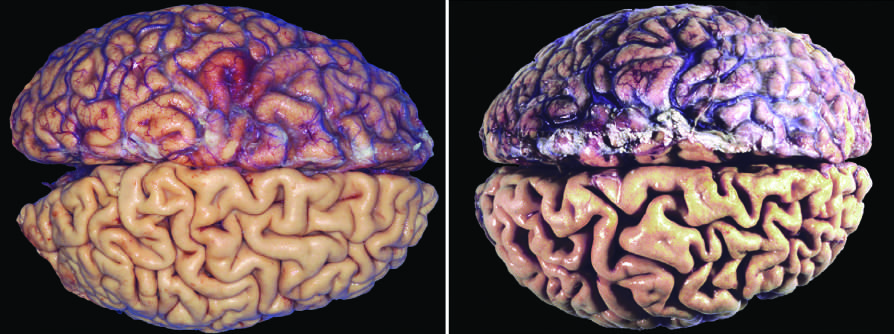s atrophy of the brain caused by aging and reduced blood supply?
Answer the question using a single word or phrase. Yes 